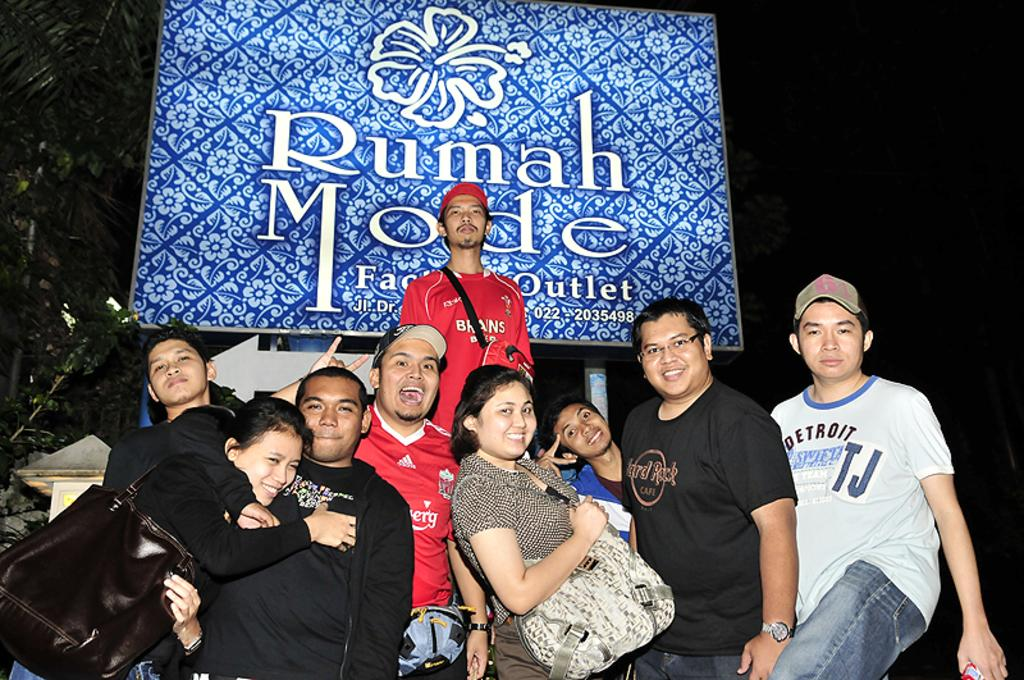How many people are in the image? There are persons in the image. What is the facial expression of the persons in the image? The persons are smiling. What is behind the persons in the image? The persons are standing in front of a board. What is written or depicted on the board? There is text on the board, and there are colorful designs on the board. How many beds can be seen in the image? There are no beds present in the image. Did the persons in the image experience an earthquake? There is no indication of an earthquake or any related effects in the image. 